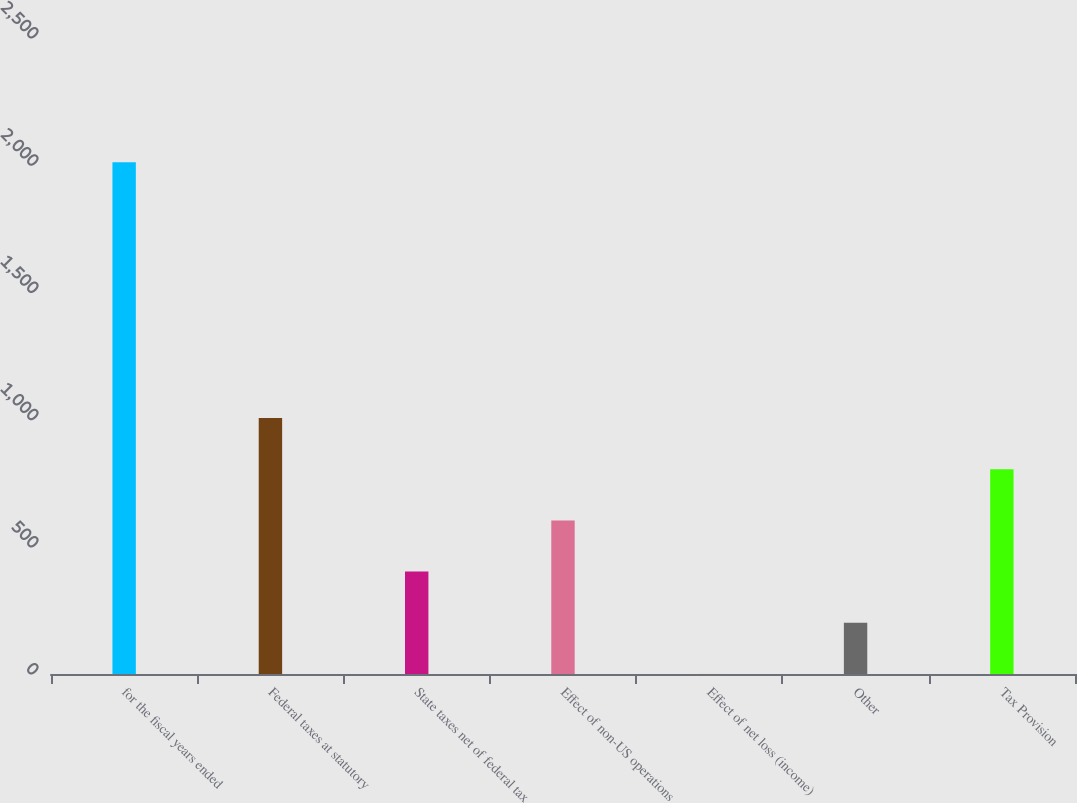Convert chart to OTSL. <chart><loc_0><loc_0><loc_500><loc_500><bar_chart><fcel>for the fiscal years ended<fcel>Federal taxes at statutory<fcel>State taxes net of federal tax<fcel>Effect of non-US operations<fcel>Effect of net loss (income)<fcel>Other<fcel>Tax Provision<nl><fcel>2012<fcel>1006.1<fcel>402.56<fcel>603.74<fcel>0.2<fcel>201.38<fcel>804.92<nl></chart> 